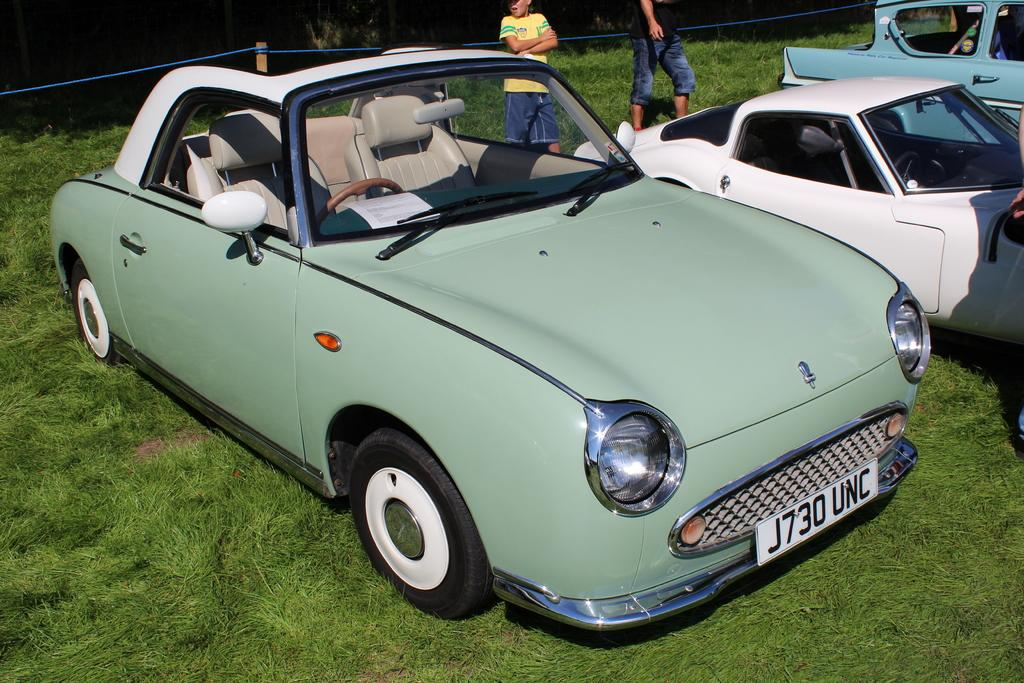What is the unusual location for the parked cars in the image? The cars are parked on the grass in the image. How many people can be seen in the image? There are two people standing in the image. What can be seen in the background of the image? There is a fence visible in the background of the image. What type of shoes are the people wearing in the image? There is no information about the shoes the people are wearing in the image. 